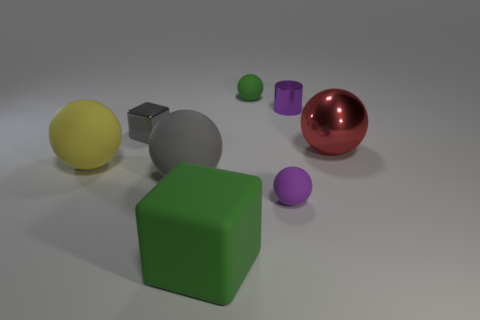Are there the same number of big rubber cubes that are right of the green cube and gray rubber objects on the right side of the big red metal sphere?
Offer a terse response. Yes. There is a small rubber thing on the left side of the purple thing to the left of the purple metal object; what shape is it?
Your response must be concise. Sphere. Is there another small shiny thing that has the same shape as the small gray metal thing?
Provide a succinct answer. No. How many big green cylinders are there?
Keep it short and to the point. 0. Is the material of the purple object behind the gray metallic thing the same as the small purple ball?
Your response must be concise. No. Are there any gray metal objects of the same size as the green matte cube?
Give a very brief answer. No. Does the tiny purple matte thing have the same shape as the tiny metal object that is to the left of the tiny purple metal cylinder?
Provide a short and direct response. No. There is a small object right of the small object that is in front of the gray rubber sphere; are there any large gray things that are right of it?
Offer a very short reply. No. How big is the purple matte object?
Provide a short and direct response. Small. What number of other things are the same color as the small metallic cube?
Your answer should be very brief. 1. 